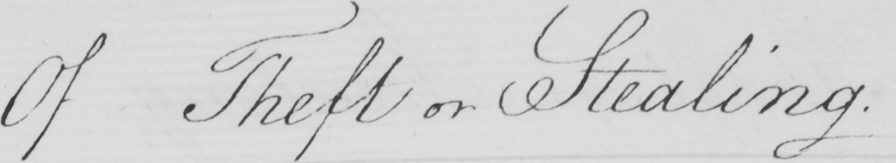What is written in this line of handwriting? Of Theft or Stealing . 